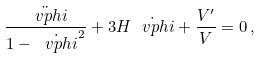<formula> <loc_0><loc_0><loc_500><loc_500>\frac { \ddot { \ v p h i } } { 1 - \dot { \ v p h i } ^ { 2 } } + 3 H \dot { \ v p h i } + \frac { V ^ { \prime } } { V } = 0 \, ,</formula> 